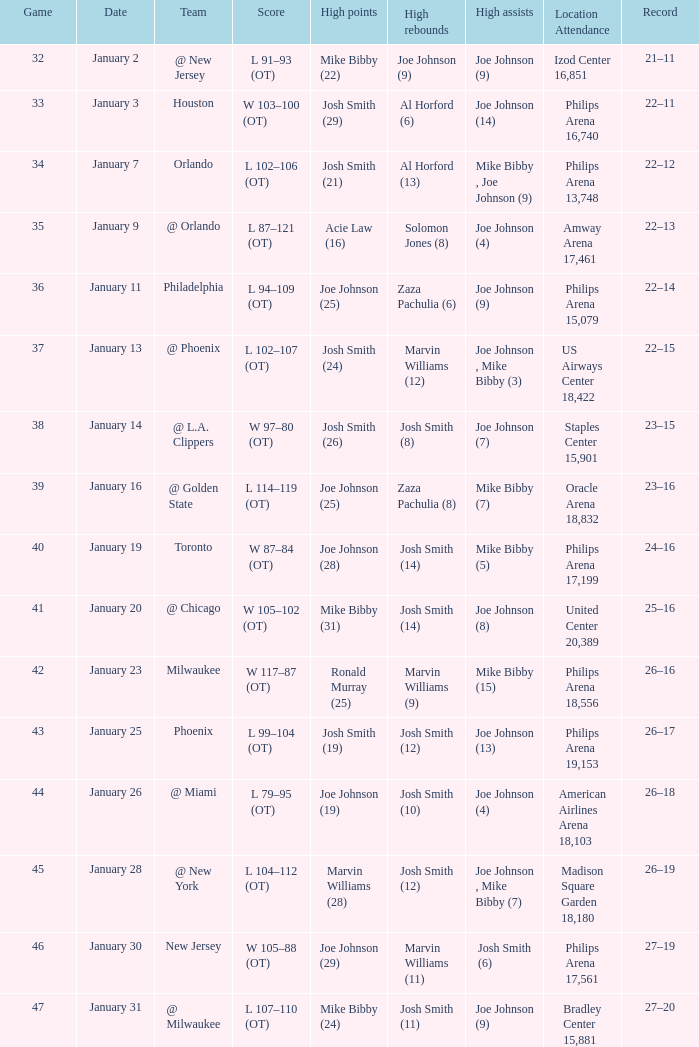What was the standing post game 37? 22–15. 